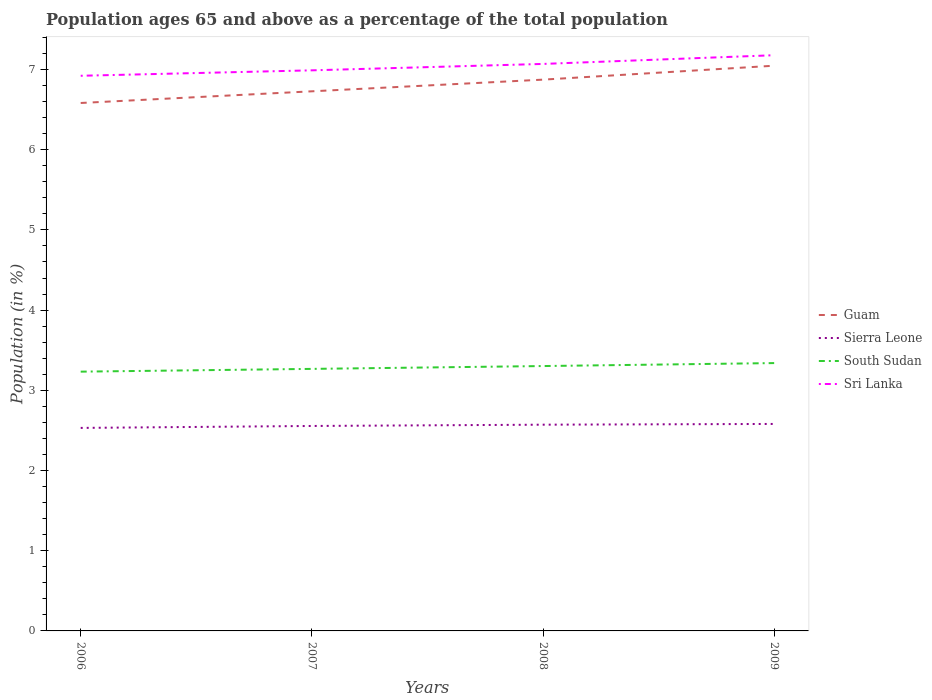How many different coloured lines are there?
Offer a terse response. 4. Is the number of lines equal to the number of legend labels?
Provide a short and direct response. Yes. Across all years, what is the maximum percentage of the population ages 65 and above in Guam?
Ensure brevity in your answer.  6.58. In which year was the percentage of the population ages 65 and above in Sierra Leone maximum?
Provide a short and direct response. 2006. What is the total percentage of the population ages 65 and above in Guam in the graph?
Your answer should be very brief. -0.29. What is the difference between the highest and the second highest percentage of the population ages 65 and above in South Sudan?
Provide a succinct answer. 0.11. How many years are there in the graph?
Give a very brief answer. 4. What is the difference between two consecutive major ticks on the Y-axis?
Your answer should be very brief. 1. Are the values on the major ticks of Y-axis written in scientific E-notation?
Give a very brief answer. No. Where does the legend appear in the graph?
Offer a very short reply. Center right. What is the title of the graph?
Provide a short and direct response. Population ages 65 and above as a percentage of the total population. Does "Lesotho" appear as one of the legend labels in the graph?
Ensure brevity in your answer.  No. What is the Population (in %) of Guam in 2006?
Your answer should be very brief. 6.58. What is the Population (in %) of Sierra Leone in 2006?
Your answer should be compact. 2.53. What is the Population (in %) in South Sudan in 2006?
Provide a succinct answer. 3.23. What is the Population (in %) of Sri Lanka in 2006?
Keep it short and to the point. 6.92. What is the Population (in %) in Guam in 2007?
Give a very brief answer. 6.73. What is the Population (in %) in Sierra Leone in 2007?
Ensure brevity in your answer.  2.56. What is the Population (in %) of South Sudan in 2007?
Make the answer very short. 3.27. What is the Population (in %) in Sri Lanka in 2007?
Your answer should be very brief. 6.99. What is the Population (in %) of Guam in 2008?
Ensure brevity in your answer.  6.87. What is the Population (in %) in Sierra Leone in 2008?
Keep it short and to the point. 2.57. What is the Population (in %) of South Sudan in 2008?
Your answer should be very brief. 3.3. What is the Population (in %) in Sri Lanka in 2008?
Offer a very short reply. 7.07. What is the Population (in %) in Guam in 2009?
Your answer should be compact. 7.05. What is the Population (in %) of Sierra Leone in 2009?
Keep it short and to the point. 2.58. What is the Population (in %) in South Sudan in 2009?
Offer a terse response. 3.34. What is the Population (in %) in Sri Lanka in 2009?
Keep it short and to the point. 7.18. Across all years, what is the maximum Population (in %) of Guam?
Your response must be concise. 7.05. Across all years, what is the maximum Population (in %) of Sierra Leone?
Your response must be concise. 2.58. Across all years, what is the maximum Population (in %) of South Sudan?
Keep it short and to the point. 3.34. Across all years, what is the maximum Population (in %) in Sri Lanka?
Provide a short and direct response. 7.18. Across all years, what is the minimum Population (in %) in Guam?
Give a very brief answer. 6.58. Across all years, what is the minimum Population (in %) of Sierra Leone?
Provide a succinct answer. 2.53. Across all years, what is the minimum Population (in %) in South Sudan?
Give a very brief answer. 3.23. Across all years, what is the minimum Population (in %) of Sri Lanka?
Make the answer very short. 6.92. What is the total Population (in %) in Guam in the graph?
Provide a succinct answer. 27.23. What is the total Population (in %) of Sierra Leone in the graph?
Keep it short and to the point. 10.24. What is the total Population (in %) of South Sudan in the graph?
Give a very brief answer. 13.14. What is the total Population (in %) in Sri Lanka in the graph?
Make the answer very short. 28.16. What is the difference between the Population (in %) in Guam in 2006 and that in 2007?
Make the answer very short. -0.15. What is the difference between the Population (in %) of Sierra Leone in 2006 and that in 2007?
Your response must be concise. -0.02. What is the difference between the Population (in %) in South Sudan in 2006 and that in 2007?
Your answer should be compact. -0.03. What is the difference between the Population (in %) of Sri Lanka in 2006 and that in 2007?
Make the answer very short. -0.07. What is the difference between the Population (in %) in Guam in 2006 and that in 2008?
Provide a short and direct response. -0.29. What is the difference between the Population (in %) in Sierra Leone in 2006 and that in 2008?
Keep it short and to the point. -0.04. What is the difference between the Population (in %) of South Sudan in 2006 and that in 2008?
Your response must be concise. -0.07. What is the difference between the Population (in %) of Sri Lanka in 2006 and that in 2008?
Ensure brevity in your answer.  -0.15. What is the difference between the Population (in %) in Guam in 2006 and that in 2009?
Offer a very short reply. -0.46. What is the difference between the Population (in %) in Sierra Leone in 2006 and that in 2009?
Provide a succinct answer. -0.05. What is the difference between the Population (in %) in South Sudan in 2006 and that in 2009?
Make the answer very short. -0.11. What is the difference between the Population (in %) in Sri Lanka in 2006 and that in 2009?
Ensure brevity in your answer.  -0.26. What is the difference between the Population (in %) of Guam in 2007 and that in 2008?
Make the answer very short. -0.15. What is the difference between the Population (in %) in Sierra Leone in 2007 and that in 2008?
Provide a succinct answer. -0.02. What is the difference between the Population (in %) in South Sudan in 2007 and that in 2008?
Your answer should be very brief. -0.04. What is the difference between the Population (in %) in Sri Lanka in 2007 and that in 2008?
Ensure brevity in your answer.  -0.08. What is the difference between the Population (in %) of Guam in 2007 and that in 2009?
Offer a terse response. -0.32. What is the difference between the Population (in %) in Sierra Leone in 2007 and that in 2009?
Offer a terse response. -0.03. What is the difference between the Population (in %) in South Sudan in 2007 and that in 2009?
Offer a terse response. -0.07. What is the difference between the Population (in %) in Sri Lanka in 2007 and that in 2009?
Provide a succinct answer. -0.19. What is the difference between the Population (in %) of Guam in 2008 and that in 2009?
Your answer should be compact. -0.17. What is the difference between the Population (in %) in Sierra Leone in 2008 and that in 2009?
Your answer should be compact. -0.01. What is the difference between the Population (in %) of South Sudan in 2008 and that in 2009?
Offer a terse response. -0.04. What is the difference between the Population (in %) of Sri Lanka in 2008 and that in 2009?
Your answer should be compact. -0.11. What is the difference between the Population (in %) in Guam in 2006 and the Population (in %) in Sierra Leone in 2007?
Offer a very short reply. 4.03. What is the difference between the Population (in %) of Guam in 2006 and the Population (in %) of South Sudan in 2007?
Give a very brief answer. 3.32. What is the difference between the Population (in %) of Guam in 2006 and the Population (in %) of Sri Lanka in 2007?
Provide a short and direct response. -0.41. What is the difference between the Population (in %) in Sierra Leone in 2006 and the Population (in %) in South Sudan in 2007?
Offer a terse response. -0.74. What is the difference between the Population (in %) of Sierra Leone in 2006 and the Population (in %) of Sri Lanka in 2007?
Offer a very short reply. -4.46. What is the difference between the Population (in %) of South Sudan in 2006 and the Population (in %) of Sri Lanka in 2007?
Your answer should be very brief. -3.76. What is the difference between the Population (in %) in Guam in 2006 and the Population (in %) in Sierra Leone in 2008?
Offer a very short reply. 4.01. What is the difference between the Population (in %) in Guam in 2006 and the Population (in %) in South Sudan in 2008?
Keep it short and to the point. 3.28. What is the difference between the Population (in %) of Guam in 2006 and the Population (in %) of Sri Lanka in 2008?
Your answer should be compact. -0.49. What is the difference between the Population (in %) of Sierra Leone in 2006 and the Population (in %) of South Sudan in 2008?
Ensure brevity in your answer.  -0.77. What is the difference between the Population (in %) of Sierra Leone in 2006 and the Population (in %) of Sri Lanka in 2008?
Give a very brief answer. -4.54. What is the difference between the Population (in %) of South Sudan in 2006 and the Population (in %) of Sri Lanka in 2008?
Your answer should be very brief. -3.84. What is the difference between the Population (in %) in Guam in 2006 and the Population (in %) in Sierra Leone in 2009?
Keep it short and to the point. 4. What is the difference between the Population (in %) in Guam in 2006 and the Population (in %) in South Sudan in 2009?
Offer a very short reply. 3.24. What is the difference between the Population (in %) of Guam in 2006 and the Population (in %) of Sri Lanka in 2009?
Offer a terse response. -0.6. What is the difference between the Population (in %) in Sierra Leone in 2006 and the Population (in %) in South Sudan in 2009?
Offer a very short reply. -0.81. What is the difference between the Population (in %) of Sierra Leone in 2006 and the Population (in %) of Sri Lanka in 2009?
Offer a terse response. -4.65. What is the difference between the Population (in %) in South Sudan in 2006 and the Population (in %) in Sri Lanka in 2009?
Offer a very short reply. -3.95. What is the difference between the Population (in %) in Guam in 2007 and the Population (in %) in Sierra Leone in 2008?
Your answer should be very brief. 4.16. What is the difference between the Population (in %) in Guam in 2007 and the Population (in %) in South Sudan in 2008?
Offer a terse response. 3.43. What is the difference between the Population (in %) of Guam in 2007 and the Population (in %) of Sri Lanka in 2008?
Provide a short and direct response. -0.34. What is the difference between the Population (in %) of Sierra Leone in 2007 and the Population (in %) of South Sudan in 2008?
Give a very brief answer. -0.75. What is the difference between the Population (in %) in Sierra Leone in 2007 and the Population (in %) in Sri Lanka in 2008?
Keep it short and to the point. -4.51. What is the difference between the Population (in %) in South Sudan in 2007 and the Population (in %) in Sri Lanka in 2008?
Offer a terse response. -3.8. What is the difference between the Population (in %) in Guam in 2007 and the Population (in %) in Sierra Leone in 2009?
Make the answer very short. 4.15. What is the difference between the Population (in %) of Guam in 2007 and the Population (in %) of South Sudan in 2009?
Your answer should be compact. 3.39. What is the difference between the Population (in %) of Guam in 2007 and the Population (in %) of Sri Lanka in 2009?
Provide a succinct answer. -0.45. What is the difference between the Population (in %) of Sierra Leone in 2007 and the Population (in %) of South Sudan in 2009?
Keep it short and to the point. -0.78. What is the difference between the Population (in %) in Sierra Leone in 2007 and the Population (in %) in Sri Lanka in 2009?
Ensure brevity in your answer.  -4.62. What is the difference between the Population (in %) of South Sudan in 2007 and the Population (in %) of Sri Lanka in 2009?
Offer a terse response. -3.91. What is the difference between the Population (in %) of Guam in 2008 and the Population (in %) of Sierra Leone in 2009?
Keep it short and to the point. 4.29. What is the difference between the Population (in %) of Guam in 2008 and the Population (in %) of South Sudan in 2009?
Ensure brevity in your answer.  3.53. What is the difference between the Population (in %) in Guam in 2008 and the Population (in %) in Sri Lanka in 2009?
Make the answer very short. -0.3. What is the difference between the Population (in %) in Sierra Leone in 2008 and the Population (in %) in South Sudan in 2009?
Give a very brief answer. -0.77. What is the difference between the Population (in %) of Sierra Leone in 2008 and the Population (in %) of Sri Lanka in 2009?
Offer a very short reply. -4.61. What is the difference between the Population (in %) of South Sudan in 2008 and the Population (in %) of Sri Lanka in 2009?
Keep it short and to the point. -3.88. What is the average Population (in %) in Guam per year?
Your answer should be compact. 6.81. What is the average Population (in %) of Sierra Leone per year?
Offer a very short reply. 2.56. What is the average Population (in %) of South Sudan per year?
Your answer should be compact. 3.29. What is the average Population (in %) of Sri Lanka per year?
Make the answer very short. 7.04. In the year 2006, what is the difference between the Population (in %) of Guam and Population (in %) of Sierra Leone?
Your answer should be compact. 4.05. In the year 2006, what is the difference between the Population (in %) of Guam and Population (in %) of South Sudan?
Offer a terse response. 3.35. In the year 2006, what is the difference between the Population (in %) of Guam and Population (in %) of Sri Lanka?
Your response must be concise. -0.34. In the year 2006, what is the difference between the Population (in %) of Sierra Leone and Population (in %) of South Sudan?
Keep it short and to the point. -0.7. In the year 2006, what is the difference between the Population (in %) in Sierra Leone and Population (in %) in Sri Lanka?
Your answer should be compact. -4.39. In the year 2006, what is the difference between the Population (in %) in South Sudan and Population (in %) in Sri Lanka?
Your answer should be very brief. -3.69. In the year 2007, what is the difference between the Population (in %) of Guam and Population (in %) of Sierra Leone?
Make the answer very short. 4.17. In the year 2007, what is the difference between the Population (in %) of Guam and Population (in %) of South Sudan?
Make the answer very short. 3.46. In the year 2007, what is the difference between the Population (in %) of Guam and Population (in %) of Sri Lanka?
Provide a short and direct response. -0.26. In the year 2007, what is the difference between the Population (in %) in Sierra Leone and Population (in %) in South Sudan?
Your answer should be very brief. -0.71. In the year 2007, what is the difference between the Population (in %) of Sierra Leone and Population (in %) of Sri Lanka?
Your answer should be very brief. -4.43. In the year 2007, what is the difference between the Population (in %) of South Sudan and Population (in %) of Sri Lanka?
Give a very brief answer. -3.72. In the year 2008, what is the difference between the Population (in %) of Guam and Population (in %) of Sierra Leone?
Provide a succinct answer. 4.3. In the year 2008, what is the difference between the Population (in %) in Guam and Population (in %) in South Sudan?
Offer a very short reply. 3.57. In the year 2008, what is the difference between the Population (in %) of Guam and Population (in %) of Sri Lanka?
Provide a succinct answer. -0.2. In the year 2008, what is the difference between the Population (in %) in Sierra Leone and Population (in %) in South Sudan?
Keep it short and to the point. -0.73. In the year 2008, what is the difference between the Population (in %) of Sierra Leone and Population (in %) of Sri Lanka?
Your response must be concise. -4.5. In the year 2008, what is the difference between the Population (in %) in South Sudan and Population (in %) in Sri Lanka?
Provide a short and direct response. -3.77. In the year 2009, what is the difference between the Population (in %) of Guam and Population (in %) of Sierra Leone?
Ensure brevity in your answer.  4.47. In the year 2009, what is the difference between the Population (in %) of Guam and Population (in %) of South Sudan?
Your response must be concise. 3.71. In the year 2009, what is the difference between the Population (in %) in Guam and Population (in %) in Sri Lanka?
Your answer should be very brief. -0.13. In the year 2009, what is the difference between the Population (in %) in Sierra Leone and Population (in %) in South Sudan?
Your response must be concise. -0.76. In the year 2009, what is the difference between the Population (in %) of Sierra Leone and Population (in %) of Sri Lanka?
Provide a succinct answer. -4.6. In the year 2009, what is the difference between the Population (in %) in South Sudan and Population (in %) in Sri Lanka?
Give a very brief answer. -3.84. What is the ratio of the Population (in %) of Guam in 2006 to that in 2007?
Offer a very short reply. 0.98. What is the ratio of the Population (in %) in Sierra Leone in 2006 to that in 2007?
Your response must be concise. 0.99. What is the ratio of the Population (in %) of Sri Lanka in 2006 to that in 2007?
Your answer should be compact. 0.99. What is the ratio of the Population (in %) of Guam in 2006 to that in 2008?
Keep it short and to the point. 0.96. What is the ratio of the Population (in %) in Sierra Leone in 2006 to that in 2008?
Your answer should be compact. 0.98. What is the ratio of the Population (in %) in South Sudan in 2006 to that in 2008?
Your answer should be very brief. 0.98. What is the ratio of the Population (in %) in Sri Lanka in 2006 to that in 2008?
Keep it short and to the point. 0.98. What is the ratio of the Population (in %) of Guam in 2006 to that in 2009?
Offer a very short reply. 0.93. What is the ratio of the Population (in %) of Sierra Leone in 2006 to that in 2009?
Your response must be concise. 0.98. What is the ratio of the Population (in %) of South Sudan in 2006 to that in 2009?
Your answer should be very brief. 0.97. What is the ratio of the Population (in %) in Sri Lanka in 2006 to that in 2009?
Offer a very short reply. 0.96. What is the ratio of the Population (in %) in Guam in 2007 to that in 2008?
Make the answer very short. 0.98. What is the ratio of the Population (in %) in Sierra Leone in 2007 to that in 2008?
Offer a terse response. 0.99. What is the ratio of the Population (in %) of South Sudan in 2007 to that in 2008?
Provide a succinct answer. 0.99. What is the ratio of the Population (in %) in Sri Lanka in 2007 to that in 2008?
Provide a short and direct response. 0.99. What is the ratio of the Population (in %) in Guam in 2007 to that in 2009?
Your answer should be very brief. 0.95. What is the ratio of the Population (in %) in Sierra Leone in 2007 to that in 2009?
Offer a terse response. 0.99. What is the ratio of the Population (in %) in South Sudan in 2007 to that in 2009?
Make the answer very short. 0.98. What is the ratio of the Population (in %) in Sri Lanka in 2007 to that in 2009?
Your answer should be compact. 0.97. What is the ratio of the Population (in %) of Guam in 2008 to that in 2009?
Your response must be concise. 0.98. What is the ratio of the Population (in %) in South Sudan in 2008 to that in 2009?
Your response must be concise. 0.99. What is the ratio of the Population (in %) in Sri Lanka in 2008 to that in 2009?
Offer a very short reply. 0.98. What is the difference between the highest and the second highest Population (in %) in Guam?
Make the answer very short. 0.17. What is the difference between the highest and the second highest Population (in %) in Sierra Leone?
Your answer should be very brief. 0.01. What is the difference between the highest and the second highest Population (in %) of South Sudan?
Offer a very short reply. 0.04. What is the difference between the highest and the second highest Population (in %) of Sri Lanka?
Give a very brief answer. 0.11. What is the difference between the highest and the lowest Population (in %) of Guam?
Provide a succinct answer. 0.46. What is the difference between the highest and the lowest Population (in %) in Sierra Leone?
Offer a terse response. 0.05. What is the difference between the highest and the lowest Population (in %) in South Sudan?
Ensure brevity in your answer.  0.11. What is the difference between the highest and the lowest Population (in %) of Sri Lanka?
Make the answer very short. 0.26. 